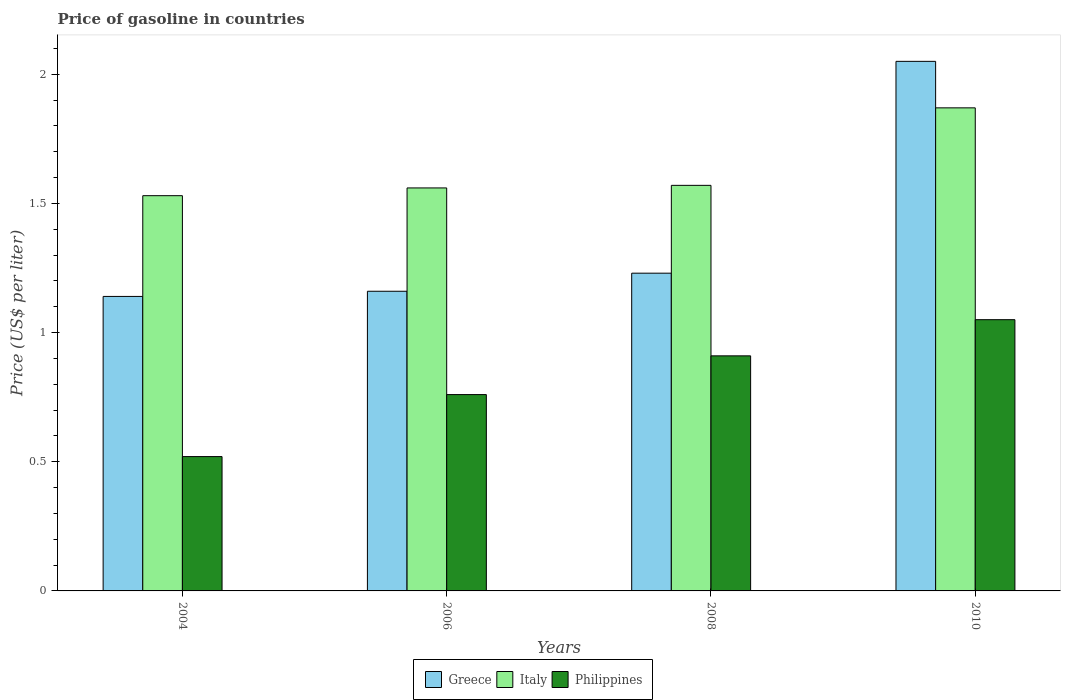How many different coloured bars are there?
Ensure brevity in your answer.  3. How many groups of bars are there?
Your answer should be very brief. 4. Are the number of bars per tick equal to the number of legend labels?
Give a very brief answer. Yes. How many bars are there on the 3rd tick from the left?
Keep it short and to the point. 3. How many bars are there on the 4th tick from the right?
Give a very brief answer. 3. What is the label of the 2nd group of bars from the left?
Provide a short and direct response. 2006. What is the price of gasoline in Italy in 2004?
Provide a short and direct response. 1.53. Across all years, what is the maximum price of gasoline in Greece?
Your answer should be compact. 2.05. Across all years, what is the minimum price of gasoline in Philippines?
Provide a succinct answer. 0.52. What is the total price of gasoline in Greece in the graph?
Provide a succinct answer. 5.58. What is the difference between the price of gasoline in Philippines in 2006 and that in 2008?
Provide a short and direct response. -0.15. What is the difference between the price of gasoline in Italy in 2008 and the price of gasoline in Greece in 2004?
Keep it short and to the point. 0.43. What is the average price of gasoline in Philippines per year?
Provide a short and direct response. 0.81. In the year 2006, what is the difference between the price of gasoline in Philippines and price of gasoline in Italy?
Your answer should be compact. -0.8. In how many years, is the price of gasoline in Philippines greater than 0.2 US$?
Your answer should be very brief. 4. What is the ratio of the price of gasoline in Italy in 2004 to that in 2010?
Provide a succinct answer. 0.82. What is the difference between the highest and the second highest price of gasoline in Italy?
Offer a terse response. 0.3. What is the difference between the highest and the lowest price of gasoline in Philippines?
Offer a terse response. 0.53. Are all the bars in the graph horizontal?
Give a very brief answer. No. What is the difference between two consecutive major ticks on the Y-axis?
Your answer should be very brief. 0.5. Where does the legend appear in the graph?
Offer a terse response. Bottom center. How many legend labels are there?
Provide a short and direct response. 3. How are the legend labels stacked?
Your answer should be very brief. Horizontal. What is the title of the graph?
Give a very brief answer. Price of gasoline in countries. Does "Lebanon" appear as one of the legend labels in the graph?
Keep it short and to the point. No. What is the label or title of the Y-axis?
Provide a short and direct response. Price (US$ per liter). What is the Price (US$ per liter) of Greece in 2004?
Provide a short and direct response. 1.14. What is the Price (US$ per liter) in Italy in 2004?
Your answer should be compact. 1.53. What is the Price (US$ per liter) in Philippines in 2004?
Offer a very short reply. 0.52. What is the Price (US$ per liter) in Greece in 2006?
Keep it short and to the point. 1.16. What is the Price (US$ per liter) in Italy in 2006?
Offer a very short reply. 1.56. What is the Price (US$ per liter) in Philippines in 2006?
Your answer should be compact. 0.76. What is the Price (US$ per liter) of Greece in 2008?
Ensure brevity in your answer.  1.23. What is the Price (US$ per liter) of Italy in 2008?
Your response must be concise. 1.57. What is the Price (US$ per liter) in Philippines in 2008?
Your answer should be very brief. 0.91. What is the Price (US$ per liter) in Greece in 2010?
Offer a very short reply. 2.05. What is the Price (US$ per liter) of Italy in 2010?
Offer a terse response. 1.87. Across all years, what is the maximum Price (US$ per liter) of Greece?
Keep it short and to the point. 2.05. Across all years, what is the maximum Price (US$ per liter) of Italy?
Ensure brevity in your answer.  1.87. Across all years, what is the maximum Price (US$ per liter) in Philippines?
Provide a short and direct response. 1.05. Across all years, what is the minimum Price (US$ per liter) of Greece?
Your response must be concise. 1.14. Across all years, what is the minimum Price (US$ per liter) in Italy?
Provide a succinct answer. 1.53. Across all years, what is the minimum Price (US$ per liter) in Philippines?
Provide a succinct answer. 0.52. What is the total Price (US$ per liter) of Greece in the graph?
Offer a terse response. 5.58. What is the total Price (US$ per liter) in Italy in the graph?
Your answer should be compact. 6.53. What is the total Price (US$ per liter) in Philippines in the graph?
Your answer should be very brief. 3.24. What is the difference between the Price (US$ per liter) in Greece in 2004 and that in 2006?
Provide a short and direct response. -0.02. What is the difference between the Price (US$ per liter) in Italy in 2004 and that in 2006?
Make the answer very short. -0.03. What is the difference between the Price (US$ per liter) in Philippines in 2004 and that in 2006?
Ensure brevity in your answer.  -0.24. What is the difference between the Price (US$ per liter) of Greece in 2004 and that in 2008?
Offer a terse response. -0.09. What is the difference between the Price (US$ per liter) in Italy in 2004 and that in 2008?
Give a very brief answer. -0.04. What is the difference between the Price (US$ per liter) in Philippines in 2004 and that in 2008?
Make the answer very short. -0.39. What is the difference between the Price (US$ per liter) in Greece in 2004 and that in 2010?
Ensure brevity in your answer.  -0.91. What is the difference between the Price (US$ per liter) of Italy in 2004 and that in 2010?
Provide a short and direct response. -0.34. What is the difference between the Price (US$ per liter) of Philippines in 2004 and that in 2010?
Ensure brevity in your answer.  -0.53. What is the difference between the Price (US$ per liter) in Greece in 2006 and that in 2008?
Keep it short and to the point. -0.07. What is the difference between the Price (US$ per liter) of Italy in 2006 and that in 2008?
Provide a succinct answer. -0.01. What is the difference between the Price (US$ per liter) of Philippines in 2006 and that in 2008?
Your answer should be compact. -0.15. What is the difference between the Price (US$ per liter) in Greece in 2006 and that in 2010?
Your answer should be compact. -0.89. What is the difference between the Price (US$ per liter) in Italy in 2006 and that in 2010?
Ensure brevity in your answer.  -0.31. What is the difference between the Price (US$ per liter) of Philippines in 2006 and that in 2010?
Ensure brevity in your answer.  -0.29. What is the difference between the Price (US$ per liter) in Greece in 2008 and that in 2010?
Provide a short and direct response. -0.82. What is the difference between the Price (US$ per liter) in Philippines in 2008 and that in 2010?
Offer a very short reply. -0.14. What is the difference between the Price (US$ per liter) of Greece in 2004 and the Price (US$ per liter) of Italy in 2006?
Provide a succinct answer. -0.42. What is the difference between the Price (US$ per liter) in Greece in 2004 and the Price (US$ per liter) in Philippines in 2006?
Provide a succinct answer. 0.38. What is the difference between the Price (US$ per liter) of Italy in 2004 and the Price (US$ per liter) of Philippines in 2006?
Give a very brief answer. 0.77. What is the difference between the Price (US$ per liter) in Greece in 2004 and the Price (US$ per liter) in Italy in 2008?
Offer a very short reply. -0.43. What is the difference between the Price (US$ per liter) of Greece in 2004 and the Price (US$ per liter) of Philippines in 2008?
Your answer should be very brief. 0.23. What is the difference between the Price (US$ per liter) of Italy in 2004 and the Price (US$ per liter) of Philippines in 2008?
Your answer should be compact. 0.62. What is the difference between the Price (US$ per liter) of Greece in 2004 and the Price (US$ per liter) of Italy in 2010?
Your response must be concise. -0.73. What is the difference between the Price (US$ per liter) of Greece in 2004 and the Price (US$ per liter) of Philippines in 2010?
Ensure brevity in your answer.  0.09. What is the difference between the Price (US$ per liter) in Italy in 2004 and the Price (US$ per liter) in Philippines in 2010?
Offer a terse response. 0.48. What is the difference between the Price (US$ per liter) of Greece in 2006 and the Price (US$ per liter) of Italy in 2008?
Your response must be concise. -0.41. What is the difference between the Price (US$ per liter) of Greece in 2006 and the Price (US$ per liter) of Philippines in 2008?
Offer a very short reply. 0.25. What is the difference between the Price (US$ per liter) in Italy in 2006 and the Price (US$ per liter) in Philippines in 2008?
Give a very brief answer. 0.65. What is the difference between the Price (US$ per liter) in Greece in 2006 and the Price (US$ per liter) in Italy in 2010?
Provide a succinct answer. -0.71. What is the difference between the Price (US$ per liter) in Greece in 2006 and the Price (US$ per liter) in Philippines in 2010?
Provide a short and direct response. 0.11. What is the difference between the Price (US$ per liter) in Italy in 2006 and the Price (US$ per liter) in Philippines in 2010?
Offer a very short reply. 0.51. What is the difference between the Price (US$ per liter) of Greece in 2008 and the Price (US$ per liter) of Italy in 2010?
Make the answer very short. -0.64. What is the difference between the Price (US$ per liter) in Greece in 2008 and the Price (US$ per liter) in Philippines in 2010?
Your answer should be very brief. 0.18. What is the difference between the Price (US$ per liter) in Italy in 2008 and the Price (US$ per liter) in Philippines in 2010?
Your response must be concise. 0.52. What is the average Price (US$ per liter) of Greece per year?
Provide a succinct answer. 1.4. What is the average Price (US$ per liter) of Italy per year?
Your answer should be compact. 1.63. What is the average Price (US$ per liter) of Philippines per year?
Provide a succinct answer. 0.81. In the year 2004, what is the difference between the Price (US$ per liter) of Greece and Price (US$ per liter) of Italy?
Your response must be concise. -0.39. In the year 2004, what is the difference between the Price (US$ per liter) of Greece and Price (US$ per liter) of Philippines?
Offer a very short reply. 0.62. In the year 2004, what is the difference between the Price (US$ per liter) in Italy and Price (US$ per liter) in Philippines?
Your answer should be compact. 1.01. In the year 2006, what is the difference between the Price (US$ per liter) of Greece and Price (US$ per liter) of Philippines?
Give a very brief answer. 0.4. In the year 2006, what is the difference between the Price (US$ per liter) in Italy and Price (US$ per liter) in Philippines?
Your answer should be compact. 0.8. In the year 2008, what is the difference between the Price (US$ per liter) in Greece and Price (US$ per liter) in Italy?
Offer a very short reply. -0.34. In the year 2008, what is the difference between the Price (US$ per liter) in Greece and Price (US$ per liter) in Philippines?
Your answer should be compact. 0.32. In the year 2008, what is the difference between the Price (US$ per liter) in Italy and Price (US$ per liter) in Philippines?
Offer a very short reply. 0.66. In the year 2010, what is the difference between the Price (US$ per liter) of Greece and Price (US$ per liter) of Italy?
Your answer should be compact. 0.18. In the year 2010, what is the difference between the Price (US$ per liter) in Greece and Price (US$ per liter) in Philippines?
Provide a succinct answer. 1. In the year 2010, what is the difference between the Price (US$ per liter) of Italy and Price (US$ per liter) of Philippines?
Your answer should be compact. 0.82. What is the ratio of the Price (US$ per liter) in Greece in 2004 to that in 2006?
Offer a terse response. 0.98. What is the ratio of the Price (US$ per liter) in Italy in 2004 to that in 2006?
Ensure brevity in your answer.  0.98. What is the ratio of the Price (US$ per liter) in Philippines in 2004 to that in 2006?
Your answer should be very brief. 0.68. What is the ratio of the Price (US$ per liter) in Greece in 2004 to that in 2008?
Ensure brevity in your answer.  0.93. What is the ratio of the Price (US$ per liter) in Italy in 2004 to that in 2008?
Your answer should be compact. 0.97. What is the ratio of the Price (US$ per liter) in Greece in 2004 to that in 2010?
Give a very brief answer. 0.56. What is the ratio of the Price (US$ per liter) of Italy in 2004 to that in 2010?
Provide a succinct answer. 0.82. What is the ratio of the Price (US$ per liter) of Philippines in 2004 to that in 2010?
Give a very brief answer. 0.5. What is the ratio of the Price (US$ per liter) of Greece in 2006 to that in 2008?
Ensure brevity in your answer.  0.94. What is the ratio of the Price (US$ per liter) of Philippines in 2006 to that in 2008?
Keep it short and to the point. 0.84. What is the ratio of the Price (US$ per liter) of Greece in 2006 to that in 2010?
Your answer should be compact. 0.57. What is the ratio of the Price (US$ per liter) in Italy in 2006 to that in 2010?
Keep it short and to the point. 0.83. What is the ratio of the Price (US$ per liter) of Philippines in 2006 to that in 2010?
Offer a terse response. 0.72. What is the ratio of the Price (US$ per liter) in Greece in 2008 to that in 2010?
Make the answer very short. 0.6. What is the ratio of the Price (US$ per liter) of Italy in 2008 to that in 2010?
Provide a short and direct response. 0.84. What is the ratio of the Price (US$ per liter) of Philippines in 2008 to that in 2010?
Offer a terse response. 0.87. What is the difference between the highest and the second highest Price (US$ per liter) of Greece?
Your answer should be very brief. 0.82. What is the difference between the highest and the second highest Price (US$ per liter) of Italy?
Your answer should be very brief. 0.3. What is the difference between the highest and the second highest Price (US$ per liter) of Philippines?
Your answer should be compact. 0.14. What is the difference between the highest and the lowest Price (US$ per liter) in Greece?
Ensure brevity in your answer.  0.91. What is the difference between the highest and the lowest Price (US$ per liter) of Italy?
Offer a very short reply. 0.34. What is the difference between the highest and the lowest Price (US$ per liter) of Philippines?
Your response must be concise. 0.53. 